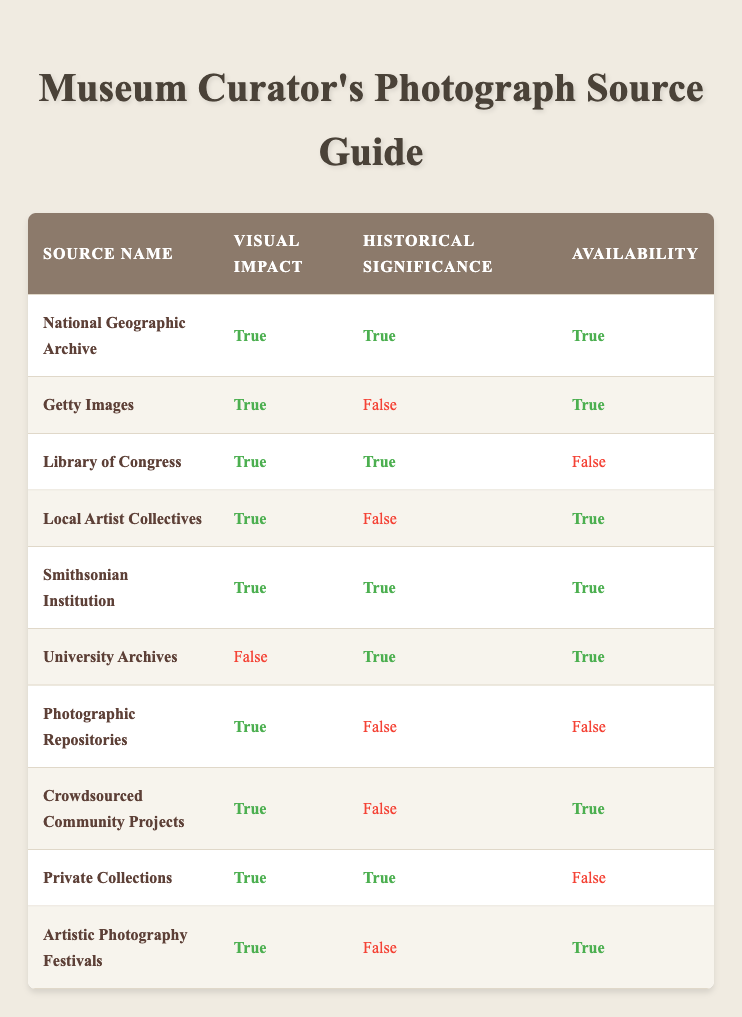What source has both visual impact and historical significance and is available? From the table, we can scan through the rows looking for sources where 'Visual Impact' and 'Historical Significance' are both marked as true, and 'Availability' is also true. The sources that meet these criteria are: National Geographic Archive and Smithsonian Institution.
Answer: National Geographic Archive, Smithsonian Institution Which source has high visual impact but low historical significance? Here, we need to find sources where 'Visual Impact' is true and 'Historical Significance' is false. By scanning the table, the applicable sources are Getty Images, Local Artist Collectives, Crowdsourced Community Projects, Artistic Photography Festivals, and Photographic Repositories.
Answer: Getty Images, Local Artist Collectives, Crowdsourced Community Projects, Artistic Photography Festivals, Photographic Repositories Is the Library of Congress available for use? The 'Availability' column for the Library of Congress shows false, indicating that it is not available for use.
Answer: No What is the total number of sources that have visual impact? To find this total, we need to count all the sources where 'Visual Impact' is true. By examining the table, we count 8 sources out of the 10 that fulfill this condition, giving a total of 8 sources with visual impact.
Answer: 8 Which sources are not available for use? We look at the 'Availability' column for each source and identify those marked as false. They are Library of Congress, Photographic Repositories, and Private Collections.
Answer: Library of Congress, Photographic Repositories, Private Collections What percentage of sources are both visually impactful and historically significant? First, we count the total number of sources in the table, which is 10. Next, we identify the sources that are both visually impactful and historically significant. They are National Geographic Archive, Library of Congress, Smithsonian Institution, and Private Collections, totaling 4 sources. The percentage is calculated as (4/10) * 100 = 40%.
Answer: 40% How many sources have neither visual impact nor historical significance? In the table, no source is marked as both false for 'Visual Impact' and false for 'Historical Significance'. Thus, the count for such sources is zero.
Answer: 0 Which source has the highest visual impact but is not available? We identify which source has 'Visual Impact' marked as true but 'Availability' marked as false. Scanning through the table, the sources meeting this criterion include Library of Congress and Private Collections. Both have high visual impact but are not accessible.
Answer: Library of Congress, Private Collections What is the average visual impact value among all sources? Given that each source is marked true (1) or false (0) for visual impact, we can sum the values. There are 8 true values, hence the total is 8 out of 10 sources. The average is calculated as 8/10 = 0.8 or 80%.
Answer: 80% 